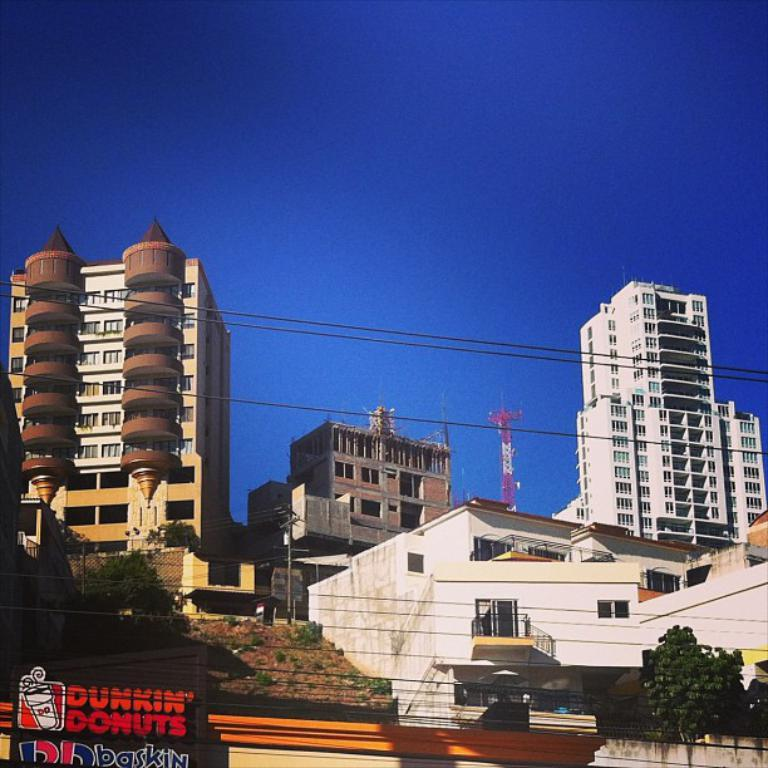What type of structures can be seen in the image? There are buildings in the image. What type of vegetation is present in the image? There are trees and shrubs in the image. What type of signage is visible in the image? There are name boards in the image. What type of architectural feature can be seen in the image? There are railings in the image. What type of construction equipment is present in the image? There are construction cranes in the image. What type of infrastructure is visible in the image? There are cables in the image. What part of the natural environment is visible in the image? The sky is visible in the image. Can you tell me where the nest of the rare bird is located in the image? There is no nest of a rare bird present in the image. What type of club can be seen in the image? There is no club present in the image. 